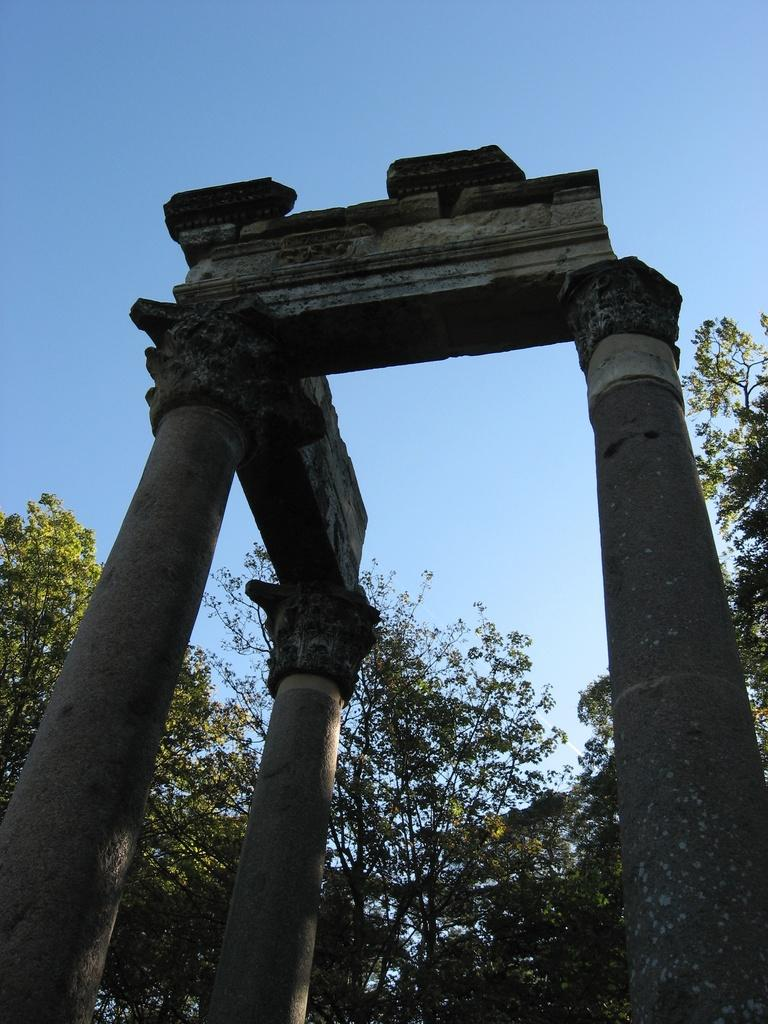What architectural features are present in the image? There are pillars in the image. What type of natural environment can be seen in the background of the image? There are trees in the background of the image. What is visible at the top of the image? The sky is visible at the top of the image. Can you describe the lunchroom in the image? There is no lunchroom present in the image. What type of jail can be seen in the image? There is no jail present in the image. 